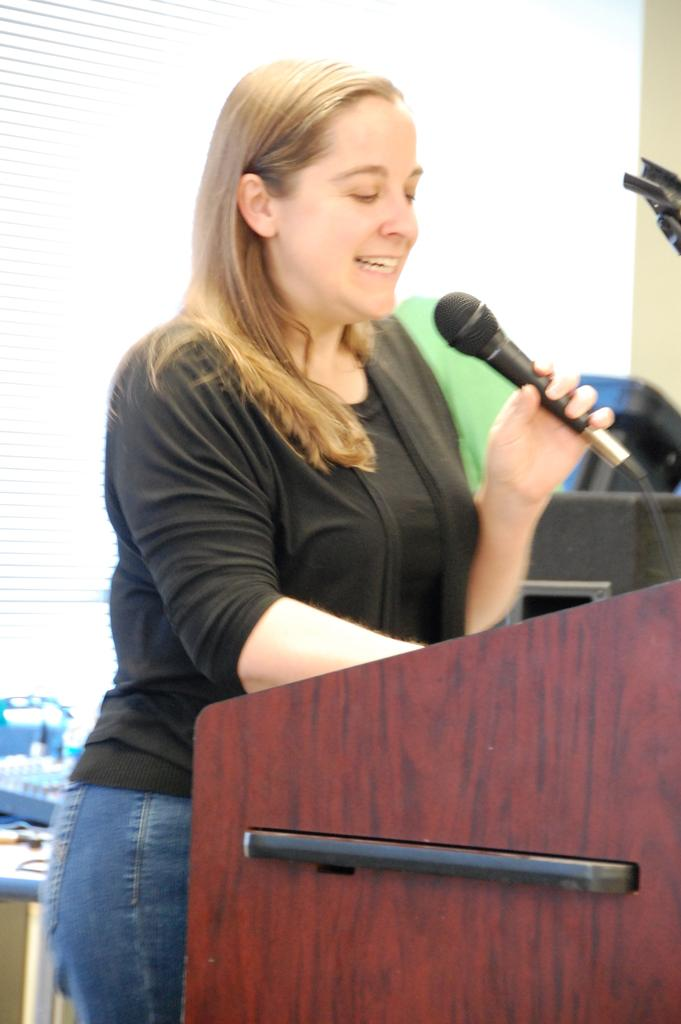Who is the main subject in the image? There is a woman in the image. What is the woman doing in the image? The woman is standing in the image. What is the woman holding in the image? The woman is holding a mic in the image. What color is the woman's top in the image? The woman is wearing a black top in the image. What type of pants is the woman wearing in the image? The woman is wearing blue jeans in the image. What is the texture of the wire that the woman is holding in the image? There is no wire present in the image; the woman is holding a mic. 